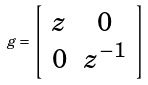Convert formula to latex. <formula><loc_0><loc_0><loc_500><loc_500>g = \left [ \begin{array} { c c } z & 0 \\ 0 & z ^ { - 1 } \end{array} \right ]</formula> 